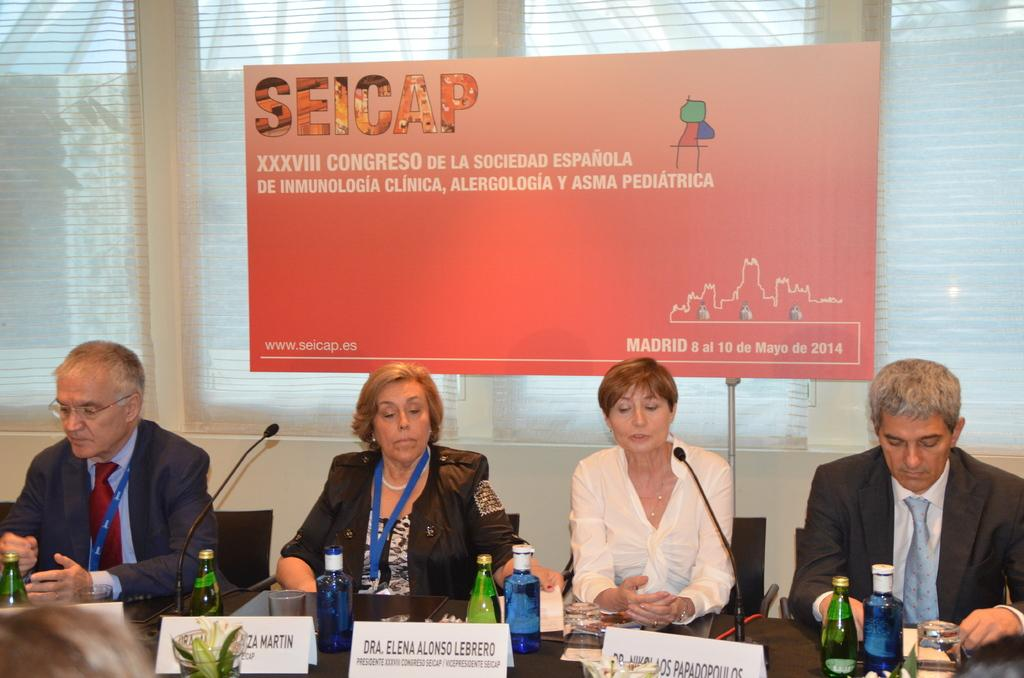<image>
Render a clear and concise summary of the photo. Several men and women sit in front of an orange sign that says Seicap at the top 